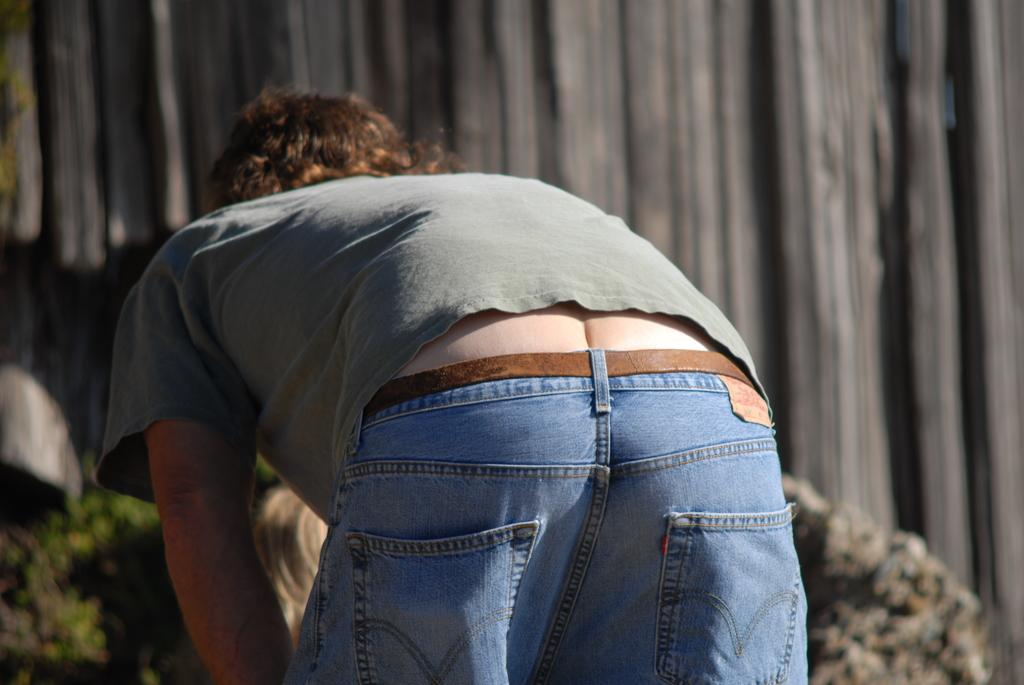Who or what is the main subject in the image? There is a person in the image. What can be seen in the background of the image? There is a wall in the background of the image. Are there any other objects or elements in the image that are not clearly visible? Yes, there are blurred objects in the image. What type of nail is being used by the person in the image? There is no nail visible in the image, and the person's activity is not described. Is the person in the image seeking medical attention at a hospital? There is no indication of a hospital or medical situation in the image. 